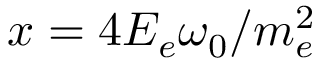<formula> <loc_0><loc_0><loc_500><loc_500>x = 4 E _ { e } \omega _ { 0 } / m _ { e } ^ { 2 }</formula> 